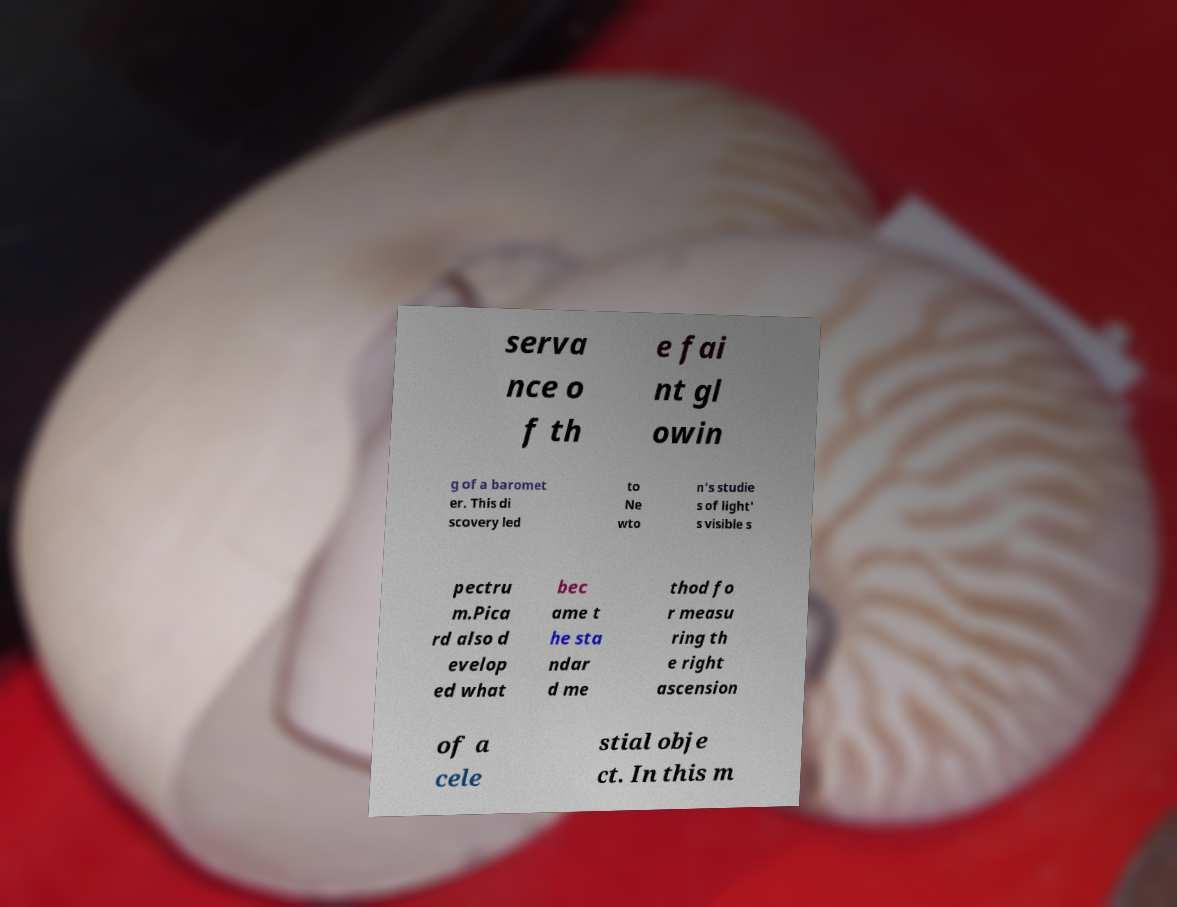Can you read and provide the text displayed in the image?This photo seems to have some interesting text. Can you extract and type it out for me? serva nce o f th e fai nt gl owin g of a baromet er. This di scovery led to Ne wto n's studie s of light' s visible s pectru m.Pica rd also d evelop ed what bec ame t he sta ndar d me thod fo r measu ring th e right ascension of a cele stial obje ct. In this m 